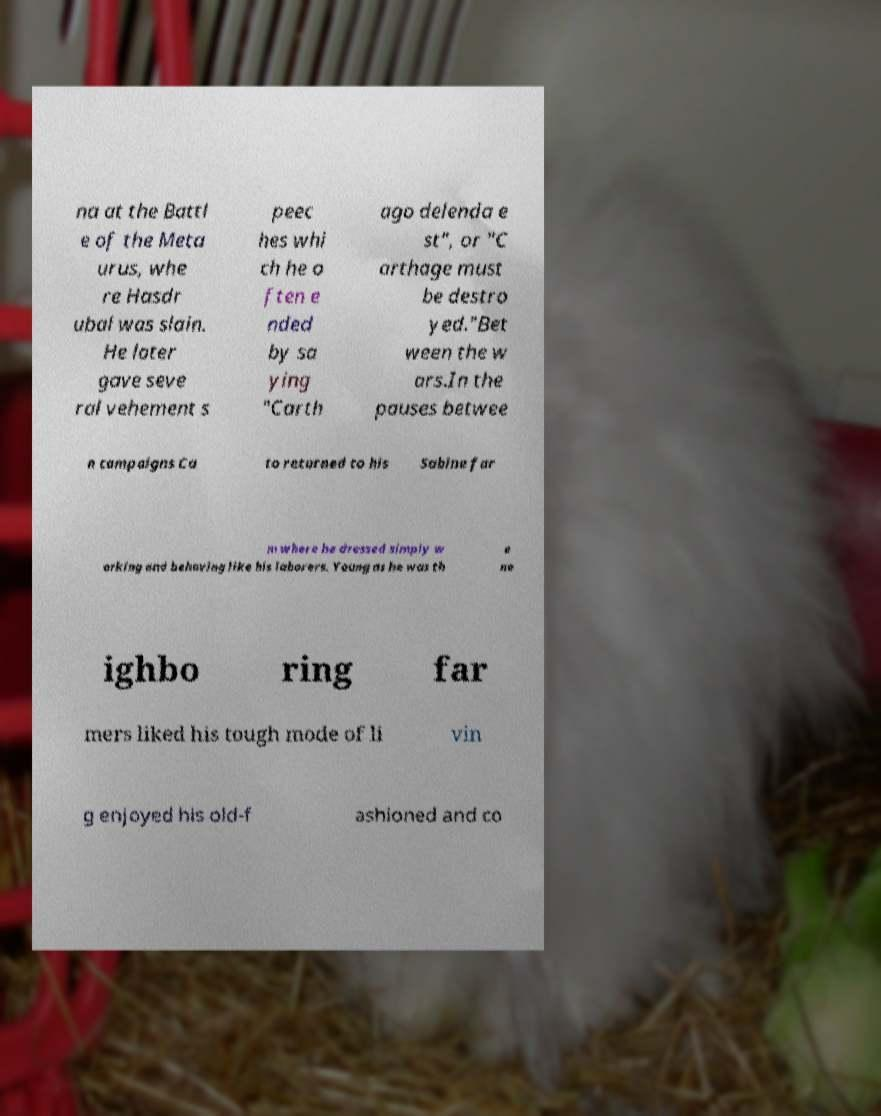What messages or text are displayed in this image? I need them in a readable, typed format. na at the Battl e of the Meta urus, whe re Hasdr ubal was slain. He later gave seve ral vehement s peec hes whi ch he o ften e nded by sa ying "Carth ago delenda e st", or "C arthage must be destro yed."Bet ween the w ars.In the pauses betwee n campaigns Ca to returned to his Sabine far m where he dressed simply w orking and behaving like his laborers. Young as he was th e ne ighbo ring far mers liked his tough mode of li vin g enjoyed his old-f ashioned and co 